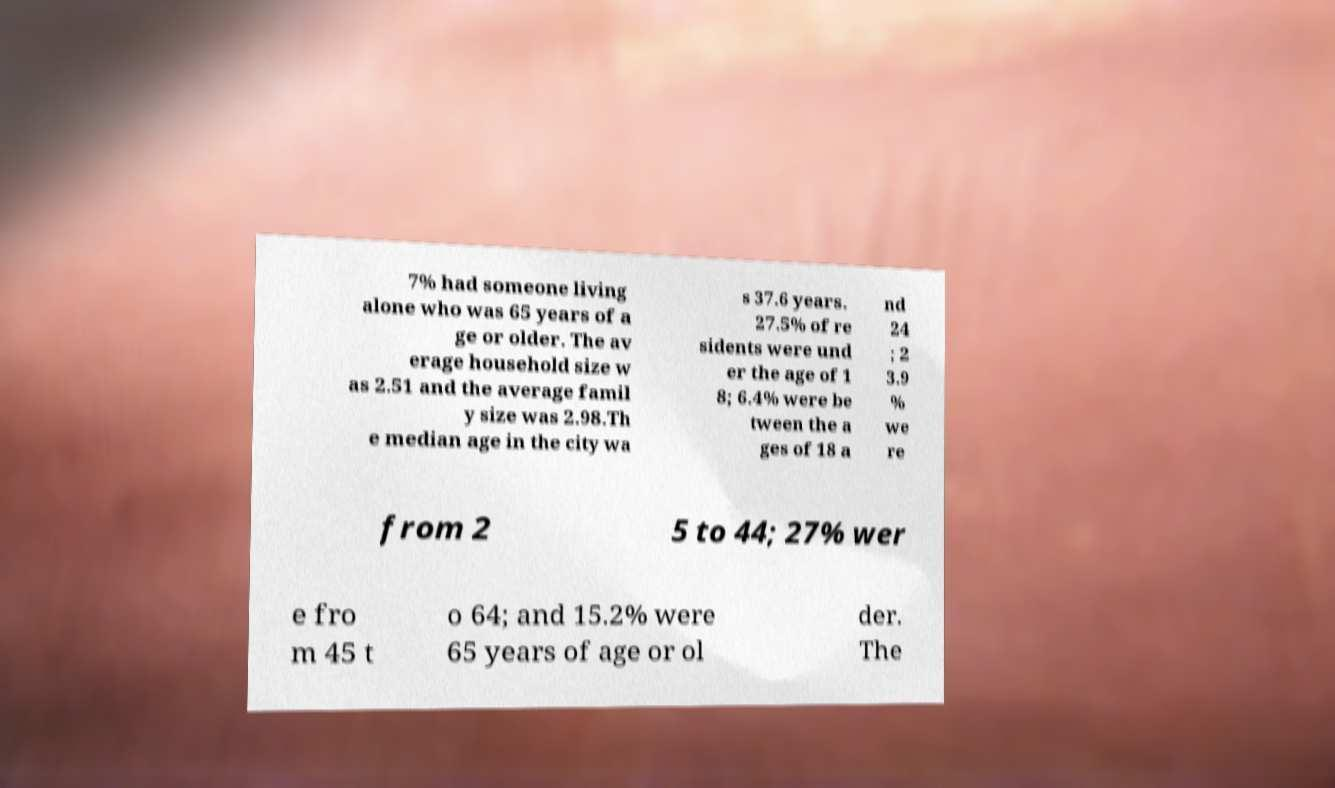Could you assist in decoding the text presented in this image and type it out clearly? 7% had someone living alone who was 65 years of a ge or older. The av erage household size w as 2.51 and the average famil y size was 2.98.Th e median age in the city wa s 37.6 years. 27.5% of re sidents were und er the age of 1 8; 6.4% were be tween the a ges of 18 a nd 24 ; 2 3.9 % we re from 2 5 to 44; 27% wer e fro m 45 t o 64; and 15.2% were 65 years of age or ol der. The 